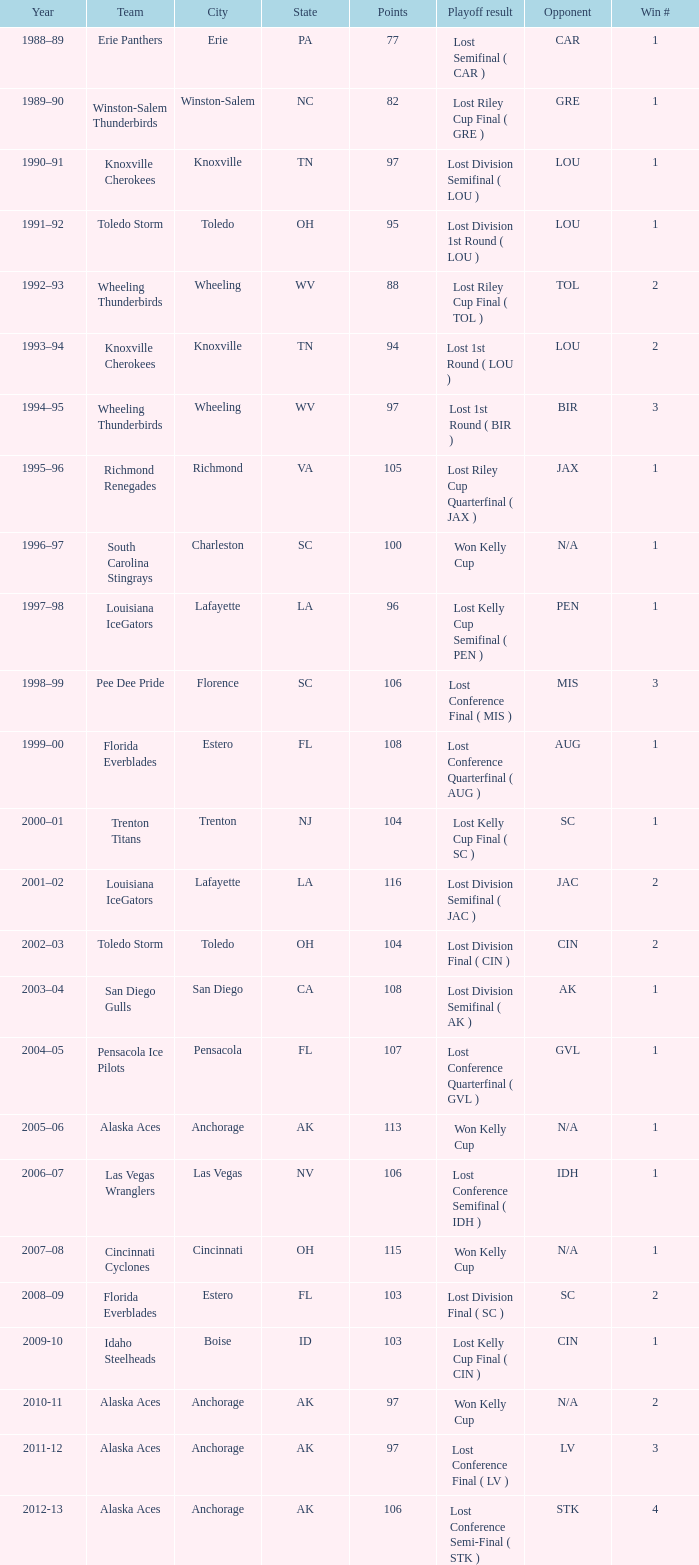What is the highest Win #, when Winner is "Knoxville Cherokees", when Playoff Result is "Lost 1st Round ( LOU )", and when Points is less than 94? None. 